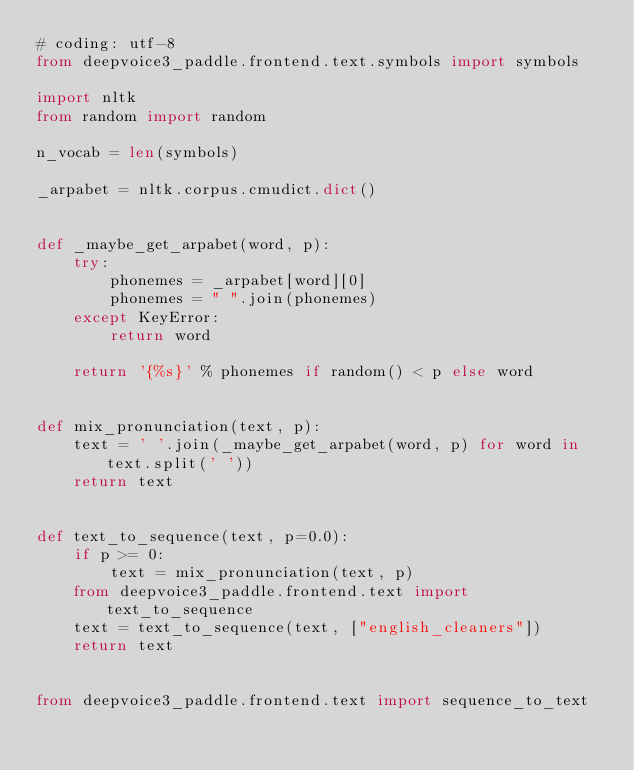<code> <loc_0><loc_0><loc_500><loc_500><_Python_># coding: utf-8
from deepvoice3_paddle.frontend.text.symbols import symbols

import nltk
from random import random

n_vocab = len(symbols)

_arpabet = nltk.corpus.cmudict.dict()


def _maybe_get_arpabet(word, p):
    try:
        phonemes = _arpabet[word][0]
        phonemes = " ".join(phonemes)
    except KeyError:
        return word

    return '{%s}' % phonemes if random() < p else word


def mix_pronunciation(text, p):
    text = ' '.join(_maybe_get_arpabet(word, p) for word in text.split(' '))
    return text


def text_to_sequence(text, p=0.0):
    if p >= 0:
        text = mix_pronunciation(text, p)
    from deepvoice3_paddle.frontend.text import text_to_sequence
    text = text_to_sequence(text, ["english_cleaners"])
    return text


from deepvoice3_paddle.frontend.text import sequence_to_text
</code> 